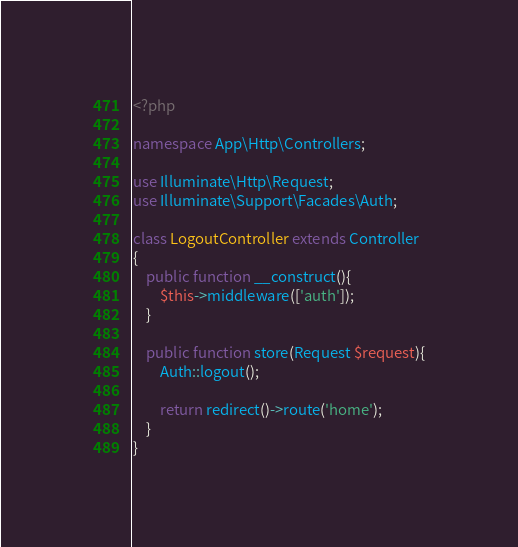<code> <loc_0><loc_0><loc_500><loc_500><_PHP_><?php

namespace App\Http\Controllers;

use Illuminate\Http\Request;
use Illuminate\Support\Facades\Auth;

class LogoutController extends Controller
{
    public function __construct(){
        $this->middleware(['auth']);
    }

    public function store(Request $request){
        Auth::logout();

        return redirect()->route('home');
    }
}
</code> 